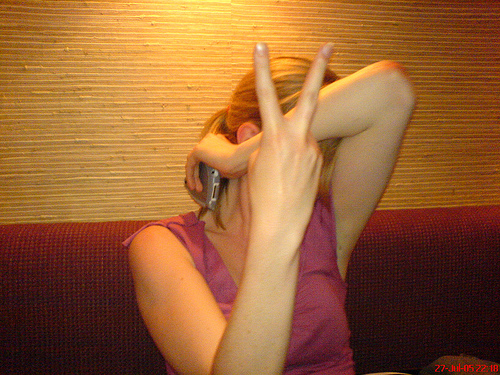<image>
Can you confirm if the woman is behind the sofa? No. The woman is not behind the sofa. From this viewpoint, the woman appears to be positioned elsewhere in the scene. Where is the finger in relation to the head? Is it in front of the head? Yes. The finger is positioned in front of the head, appearing closer to the camera viewpoint. 